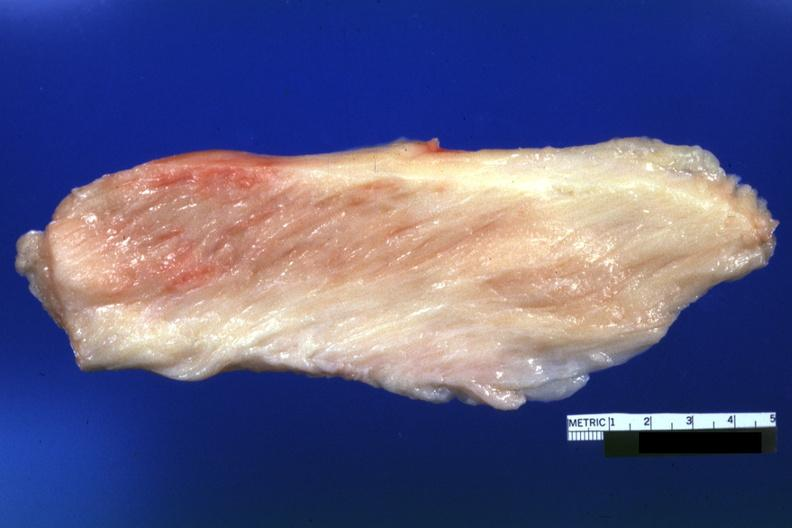does glioma show white muscle?
Answer the question using a single word or phrase. No 